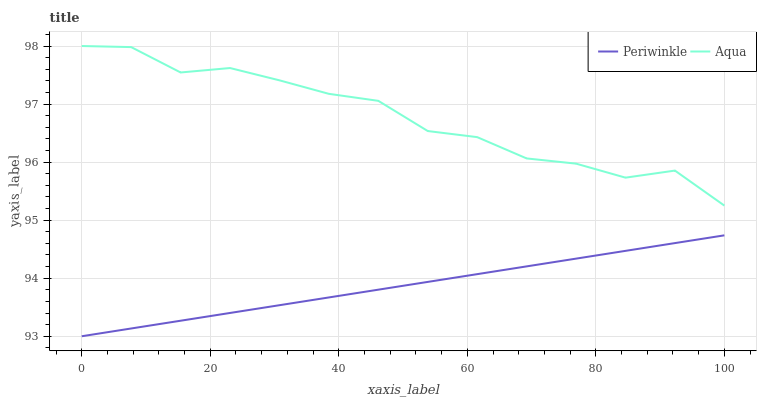Does Periwinkle have the maximum area under the curve?
Answer yes or no. No. Is Periwinkle the roughest?
Answer yes or no. No. Does Periwinkle have the highest value?
Answer yes or no. No. Is Periwinkle less than Aqua?
Answer yes or no. Yes. Is Aqua greater than Periwinkle?
Answer yes or no. Yes. Does Periwinkle intersect Aqua?
Answer yes or no. No. 